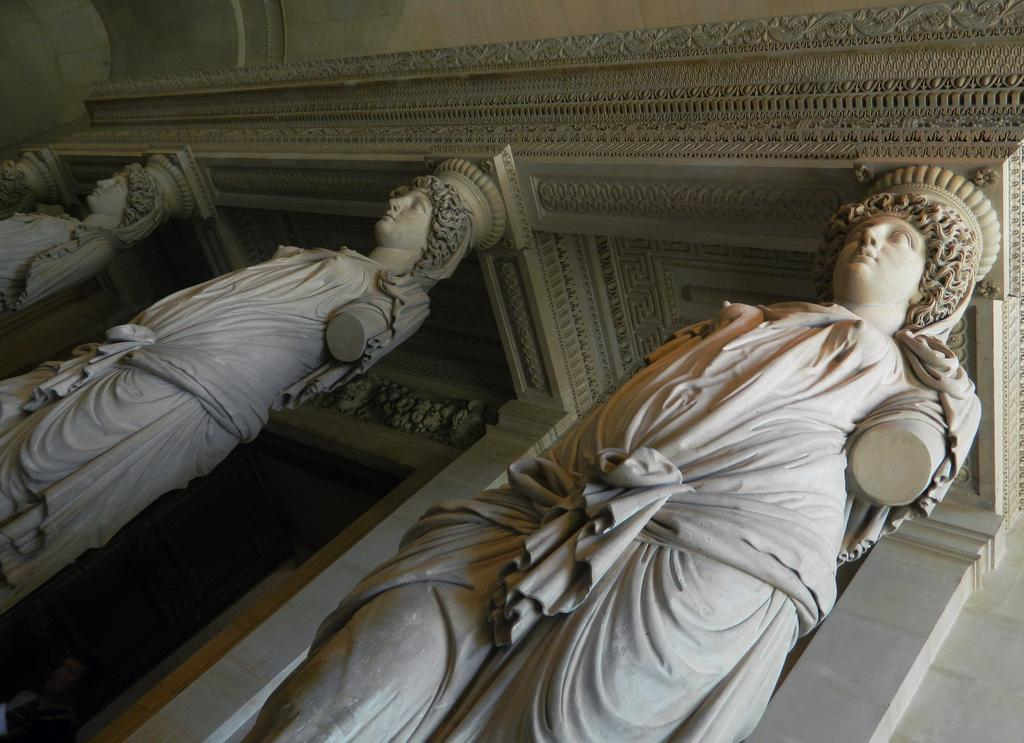What type of artwork is present in the image? There are sculptures in the image. What is located behind the sculptures? There is a wall behind the sculptures. Can you tell me how many flights the grandmother took to reach her territory in the image? There is no mention of a grandmother, flights, or territory in the image; it only features sculptures and a wall. 